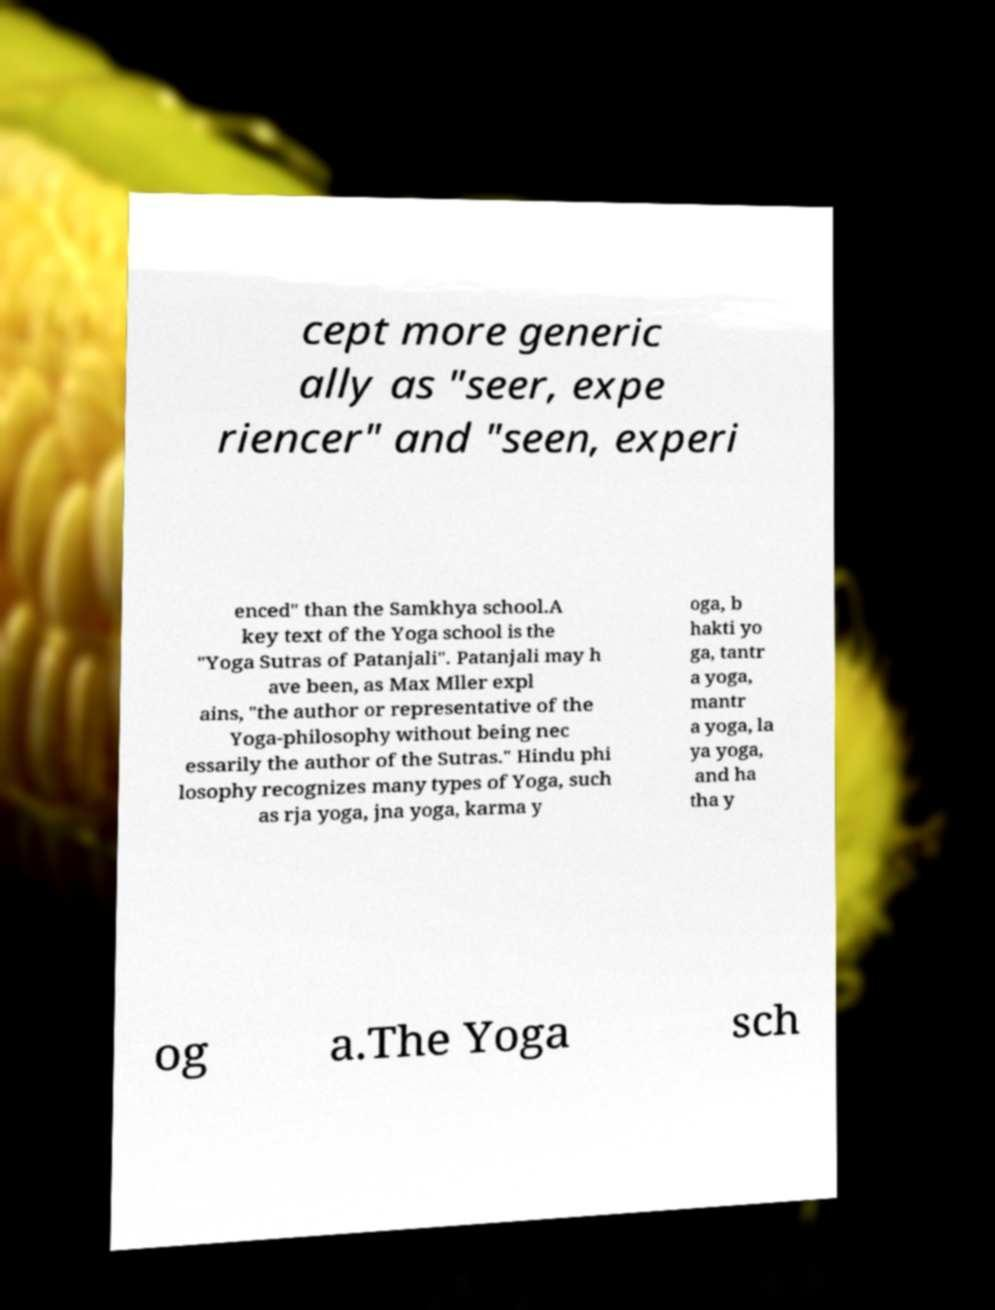There's text embedded in this image that I need extracted. Can you transcribe it verbatim? cept more generic ally as "seer, expe riencer" and "seen, experi enced" than the Samkhya school.A key text of the Yoga school is the "Yoga Sutras of Patanjali". Patanjali may h ave been, as Max Mller expl ains, "the author or representative of the Yoga-philosophy without being nec essarily the author of the Sutras." Hindu phi losophy recognizes many types of Yoga, such as rja yoga, jna yoga, karma y oga, b hakti yo ga, tantr a yoga, mantr a yoga, la ya yoga, and ha tha y og a.The Yoga sch 